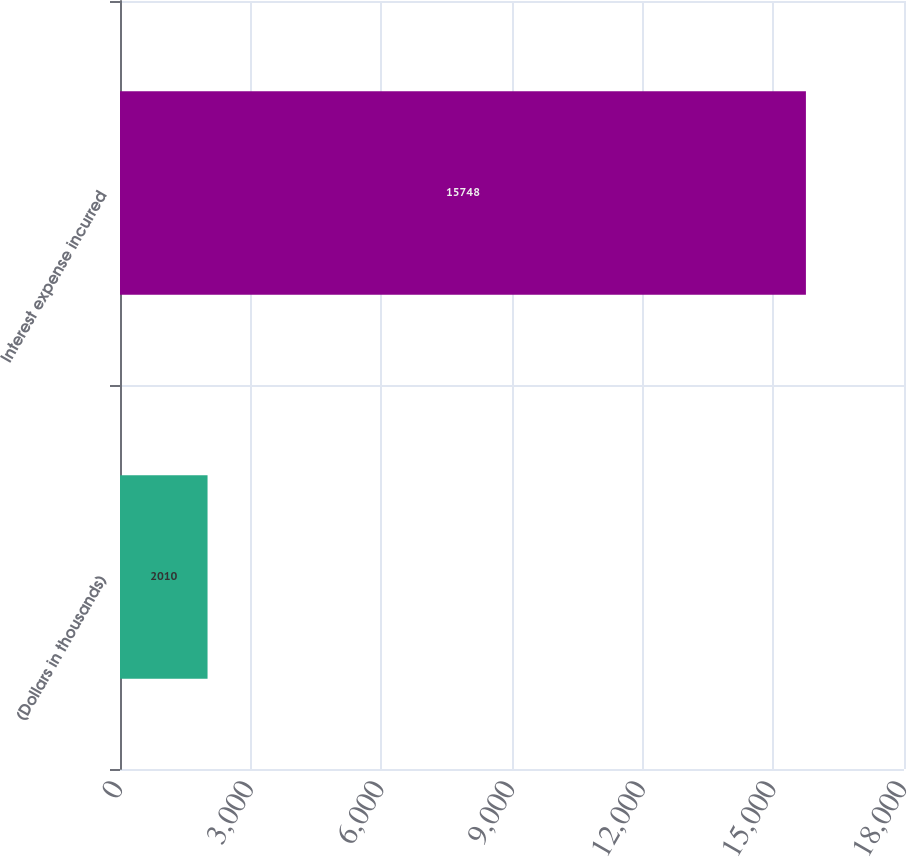Convert chart to OTSL. <chart><loc_0><loc_0><loc_500><loc_500><bar_chart><fcel>(Dollars in thousands)<fcel>Interest expense incurred<nl><fcel>2010<fcel>15748<nl></chart> 